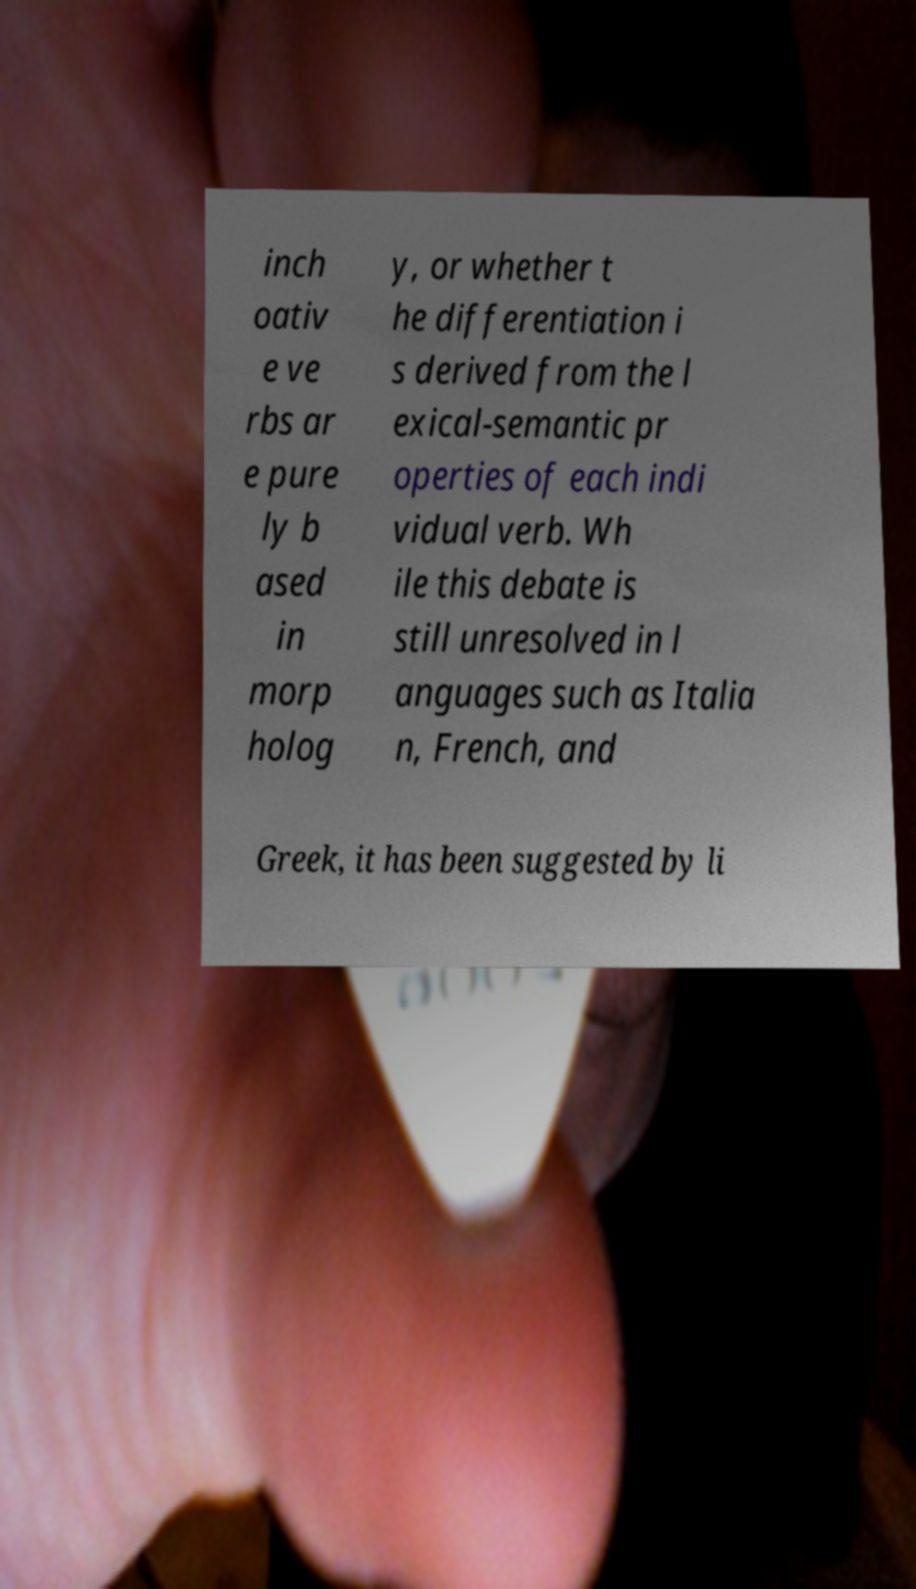For documentation purposes, I need the text within this image transcribed. Could you provide that? inch oativ e ve rbs ar e pure ly b ased in morp holog y, or whether t he differentiation i s derived from the l exical-semantic pr operties of each indi vidual verb. Wh ile this debate is still unresolved in l anguages such as Italia n, French, and Greek, it has been suggested by li 